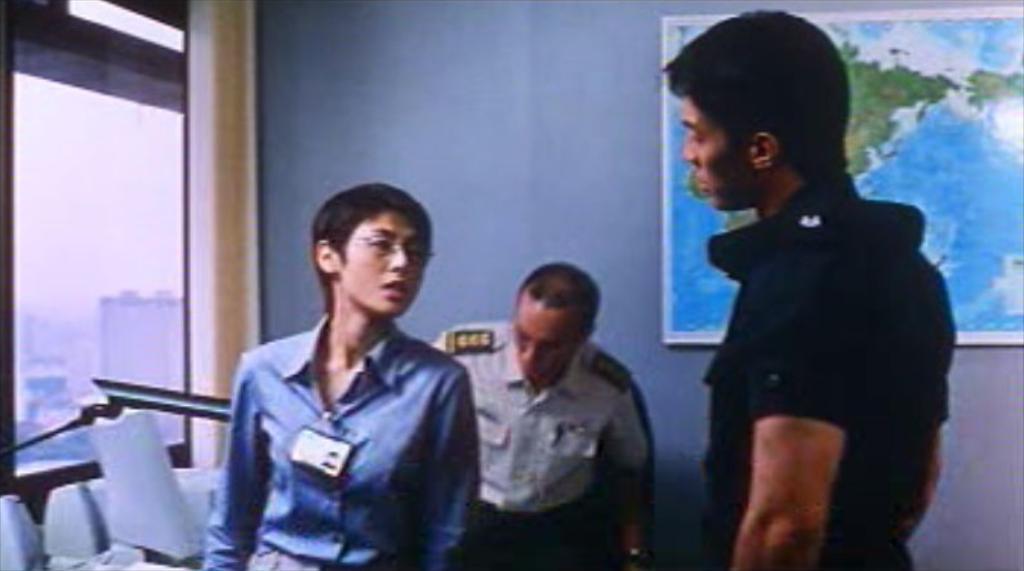Describe this image in one or two sentences. In the picture I can see a man and a woman. The man in the middle is wearing a uniform. In the background I can see a board of map attached to a wall. On the left side I can see a window and some other objects. 